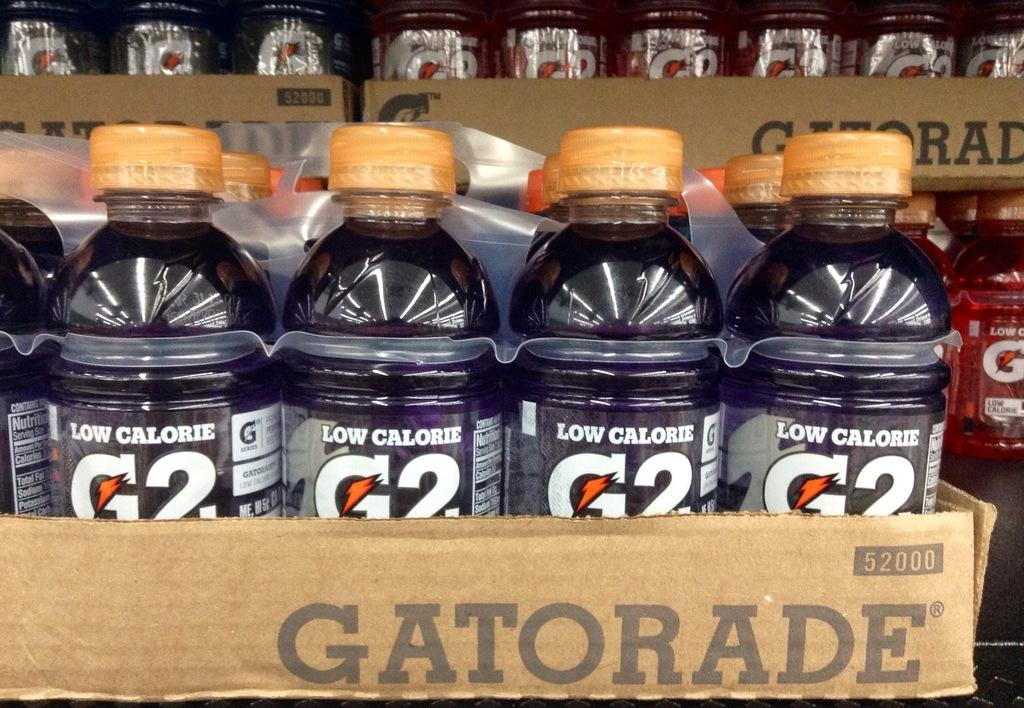<image>
Give a short and clear explanation of the subsequent image. One of the versions of the low calorie beverage called G2 is purple in color. 